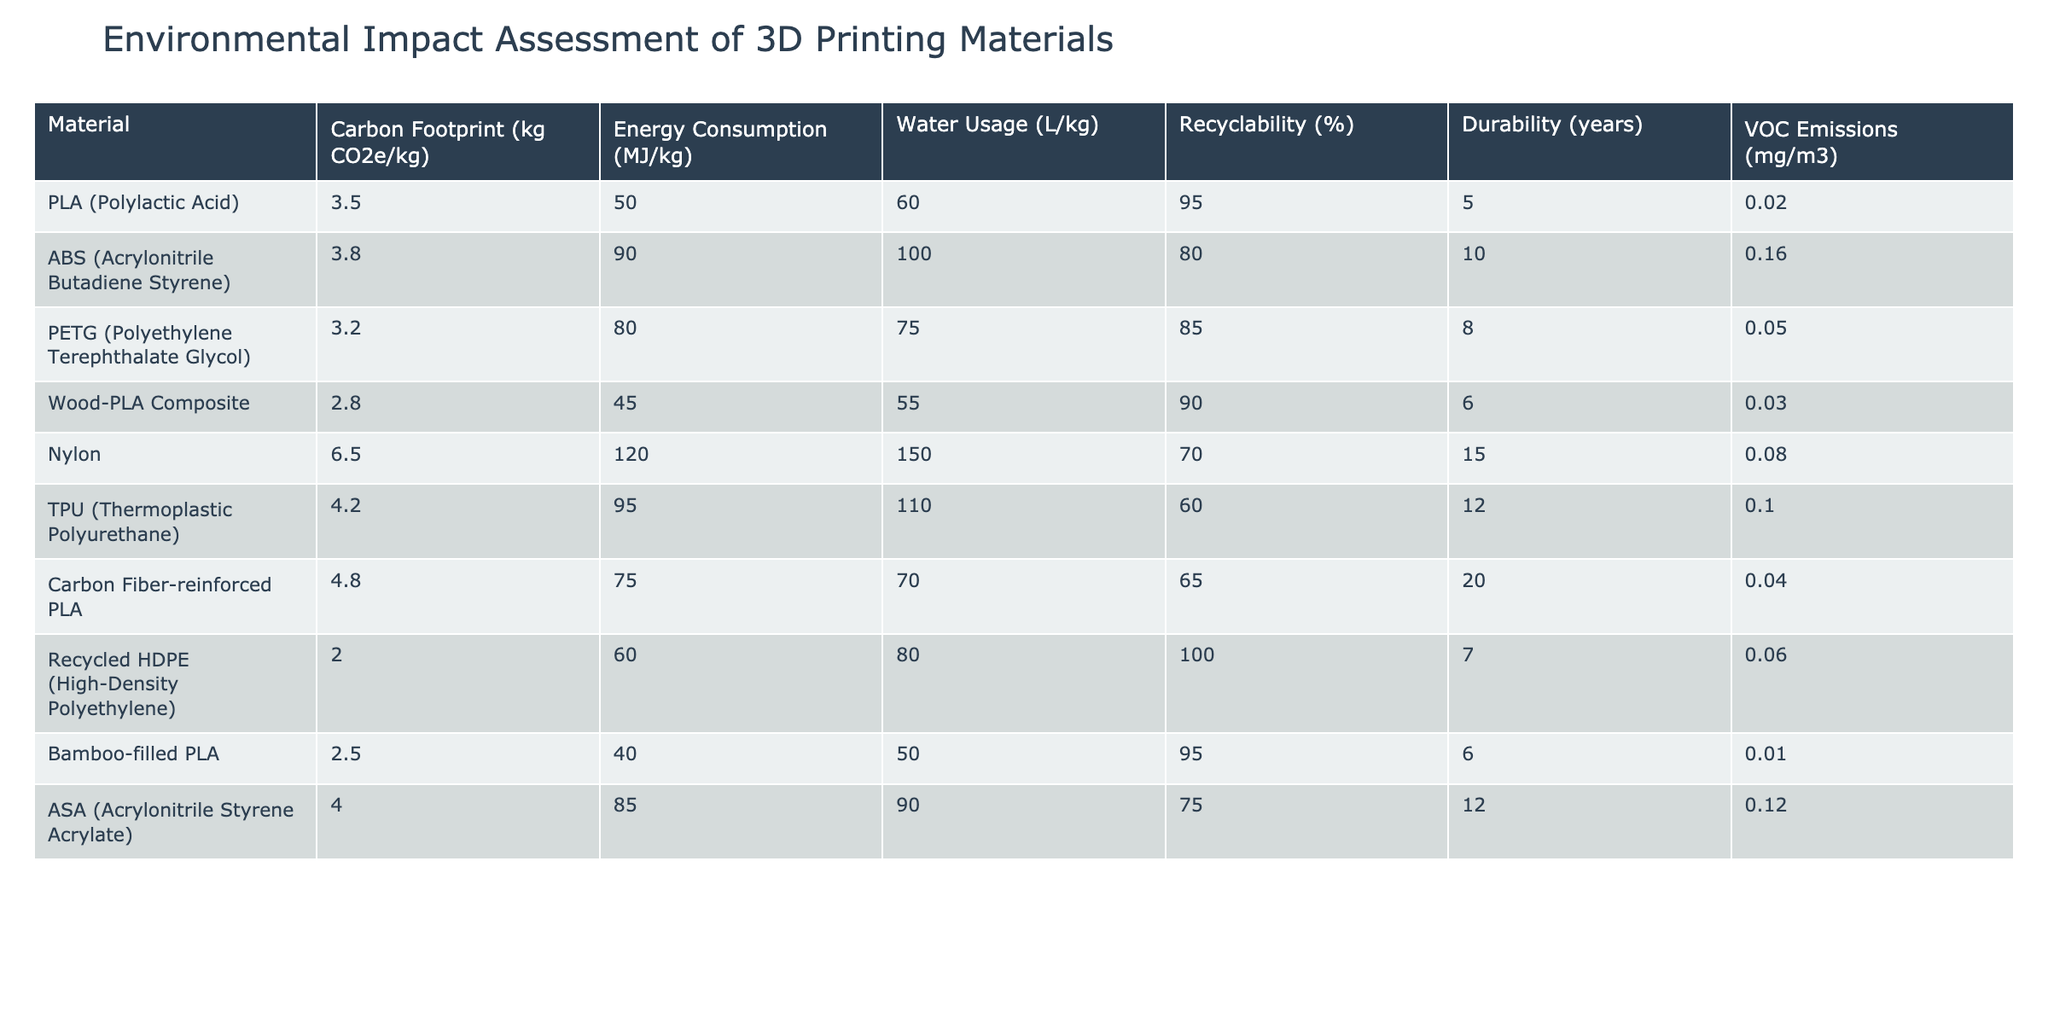What is the carbon footprint of PLA? The carbon footprint is listed in the 'Carbon Footprint' column in the table for PLA. It shows 3.5 kg CO2e/kg.
Answer: 3.5 kg CO2e/kg How many years of durability does Nylon have? The durability of Nylon is found in the 'Durability' column, where it is noted as 15 years.
Answer: 15 years Which material has the highest water usage? To find the highest water usage, I compare the values in the 'Water Usage' column. Nylon has the highest value at 150 L/kg.
Answer: Nylon What is the recyclability percentage of Recycled HDPE? The recyclability percentage is in the 'Recyclability' column for Recycled HDPE, which shows 100%.
Answer: 100% Compute the average energy consumption of all materials. First, I sum the energy consumption values: 50 + 90 + 80 + 45 + 120 + 95 + 75 + 60 + 40 + 85 = 750 MJ/kg. There are 10 materials, so the average is 750 / 10 = 75 MJ/kg.
Answer: 75 MJ/kg Which material has the lowest VOC emissions and what is that value? By looking at the 'VOC Emissions' column, I find the lowest value belongs to Bamboo-filled PLA at 0.01 mg/m3.
Answer: Bamboo-filled PLA, 0.01 mg/m3 Is it true that Wood-PLA Composite has a lower carbon footprint than ABS? I compare the carbon footprint values: Wood-PLA Composite is 2.8 kg CO2e/kg and ABS is 3.8 kg CO2e/kg. Since 2.8 is less than 3.8, the statement is true.
Answer: Yes Which two materials have a recyclability percentage of over 90%? I search the 'Recyclability' column for values greater than 90%. The materials that meet this criterion are PLA at 95% and Recycled HDPE at 100%.
Answer: PLA, Recycled HDPE What is the difference in carbon footprint between TPU and Carbon Fiber-reinforced PLA? The carbon footprint for TPU is 4.2 kg CO2e/kg and for Carbon Fiber-reinforced PLA it is 4.8 kg CO2e/kg. The difference is calculated as 4.8 - 4.2 = 0.6 kg CO2e/kg.
Answer: 0.6 kg CO2e/kg Calculate the total water usage for the materials that have a durability of 10 years or more. I identify the materials with durability of 10 years or more: ABS (100 L), Nylon (150 L), TPU (110 L), and ASA (90 L). Their total water usage is 100 + 150 + 110 + 90 = 450 L/kg.
Answer: 450 L/kg 